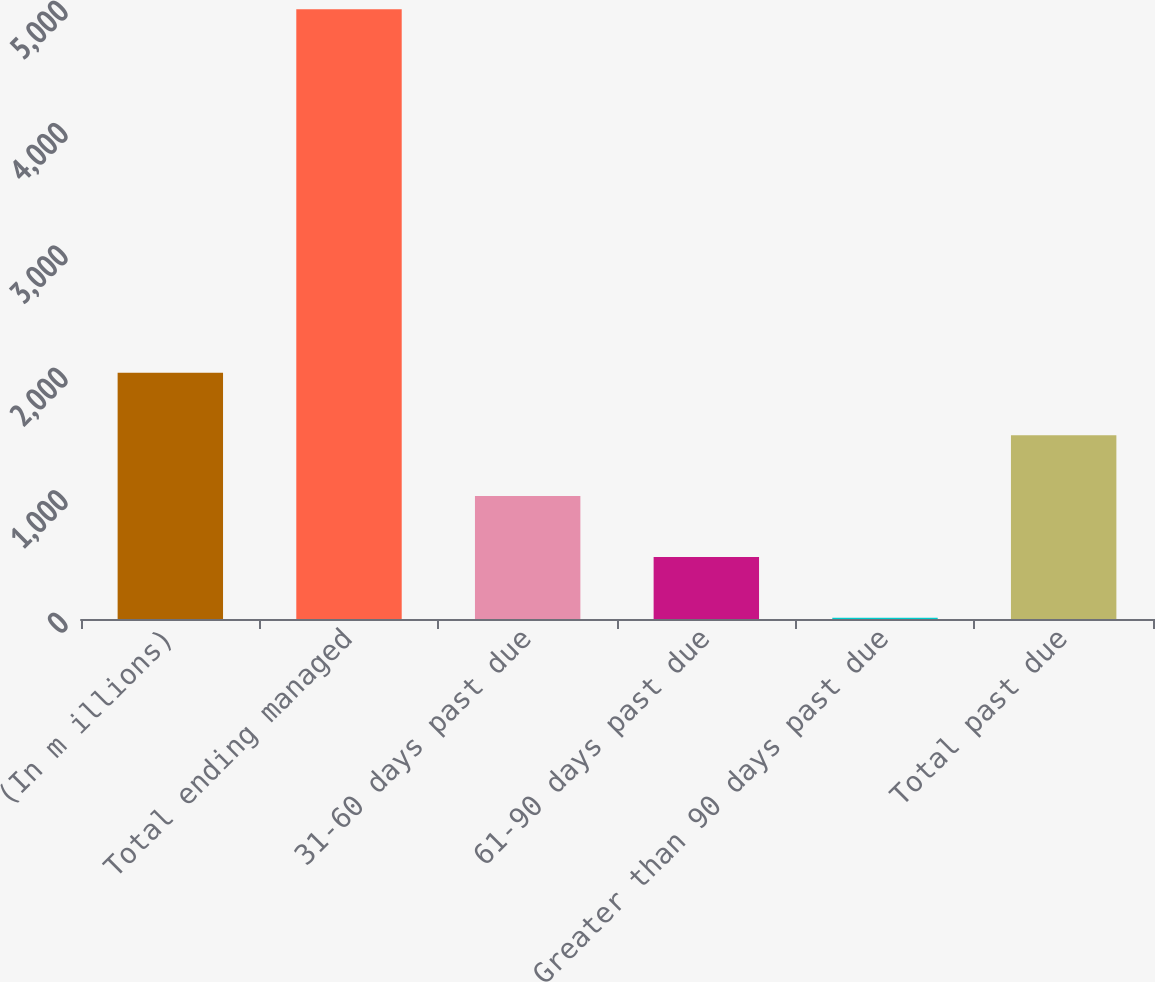Convert chart. <chart><loc_0><loc_0><loc_500><loc_500><bar_chart><fcel>(In m illions)<fcel>Total ending managed<fcel>31-60 days past due<fcel>61-90 days past due<fcel>Greater than 90 days past due<fcel>Total past due<nl><fcel>2012<fcel>4981.8<fcel>1004.04<fcel>506.82<fcel>9.6<fcel>1501.26<nl></chart> 